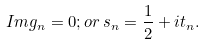<formula> <loc_0><loc_0><loc_500><loc_500>I m g _ { n } = 0 ; o r \, s _ { n } = \frac { 1 } { 2 } + i t _ { n } .</formula> 